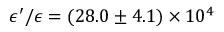<formula> <loc_0><loc_0><loc_500><loc_500>\epsilon ^ { \prime } / \epsilon = ( 2 8 . 0 \pm 4 . 1 ) \times 1 0 ^ { 4 }</formula> 